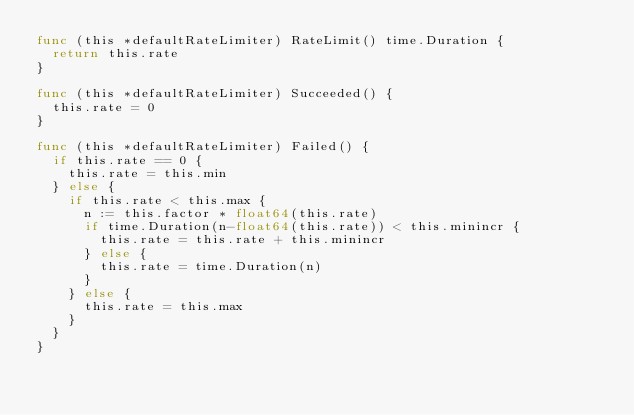<code> <loc_0><loc_0><loc_500><loc_500><_Go_>func (this *defaultRateLimiter) RateLimit() time.Duration {
	return this.rate
}

func (this *defaultRateLimiter) Succeeded() {
	this.rate = 0
}

func (this *defaultRateLimiter) Failed() {
	if this.rate == 0 {
		this.rate = this.min
	} else {
		if this.rate < this.max {
			n := this.factor * float64(this.rate)
			if time.Duration(n-float64(this.rate)) < this.minincr {
				this.rate = this.rate + this.minincr
			} else {
				this.rate = time.Duration(n)
			}
		} else {
			this.rate = this.max
		}
	}
}
</code> 